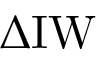Convert formula to latex. <formula><loc_0><loc_0><loc_500><loc_500>\Delta I W</formula> 